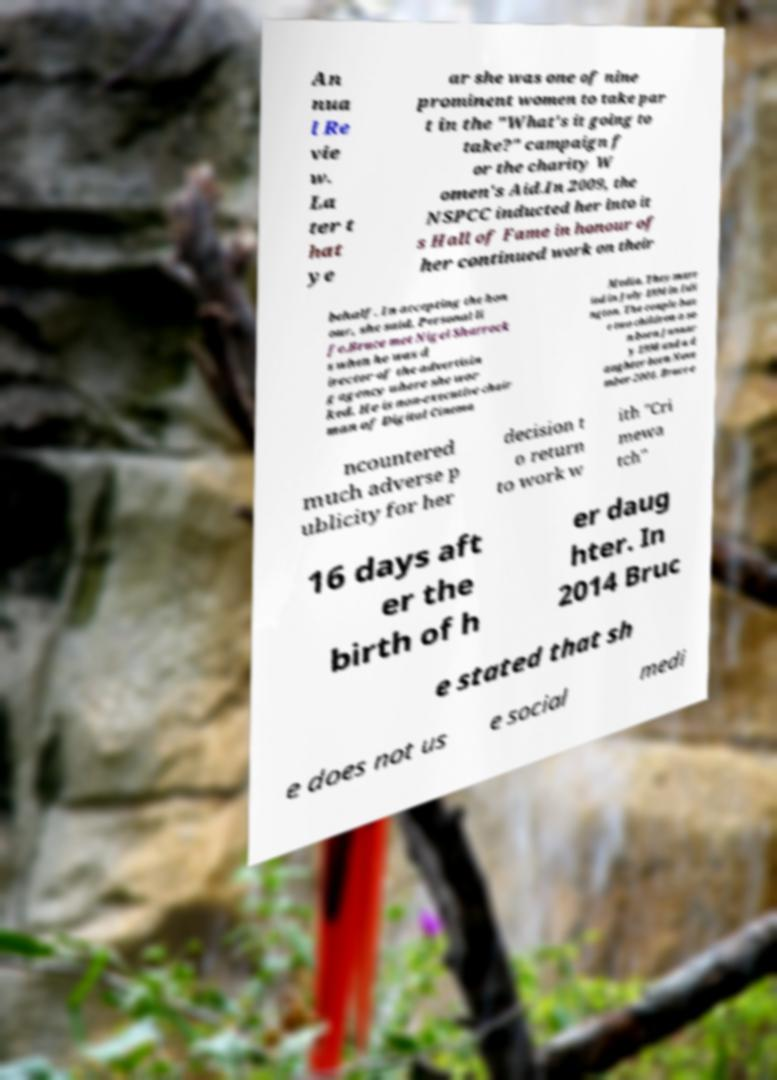Please identify and transcribe the text found in this image. An nua l Re vie w. La ter t hat ye ar she was one of nine prominent women to take par t in the "What's it going to take?" campaign f or the charity W omen's Aid.In 2009, the NSPCC inducted her into it s Hall of Fame in honour of her continued work on their behalf. In accepting the hon our, she said, Personal li fe.Bruce met Nigel Sharrock s when he was d irector of the advertisin g agency where she wor ked. He is non-executive chair man of Digital Cinema Media. They marr ied in July 1994 in Isli ngton. The couple hav e two children a so n born Januar y 1998 and a d aughter born Nove mber 2001. Bruce e ncountered much adverse p ublicity for her decision t o return to work w ith "Cri mewa tch" 16 days aft er the birth of h er daug hter. In 2014 Bruc e stated that sh e does not us e social medi 